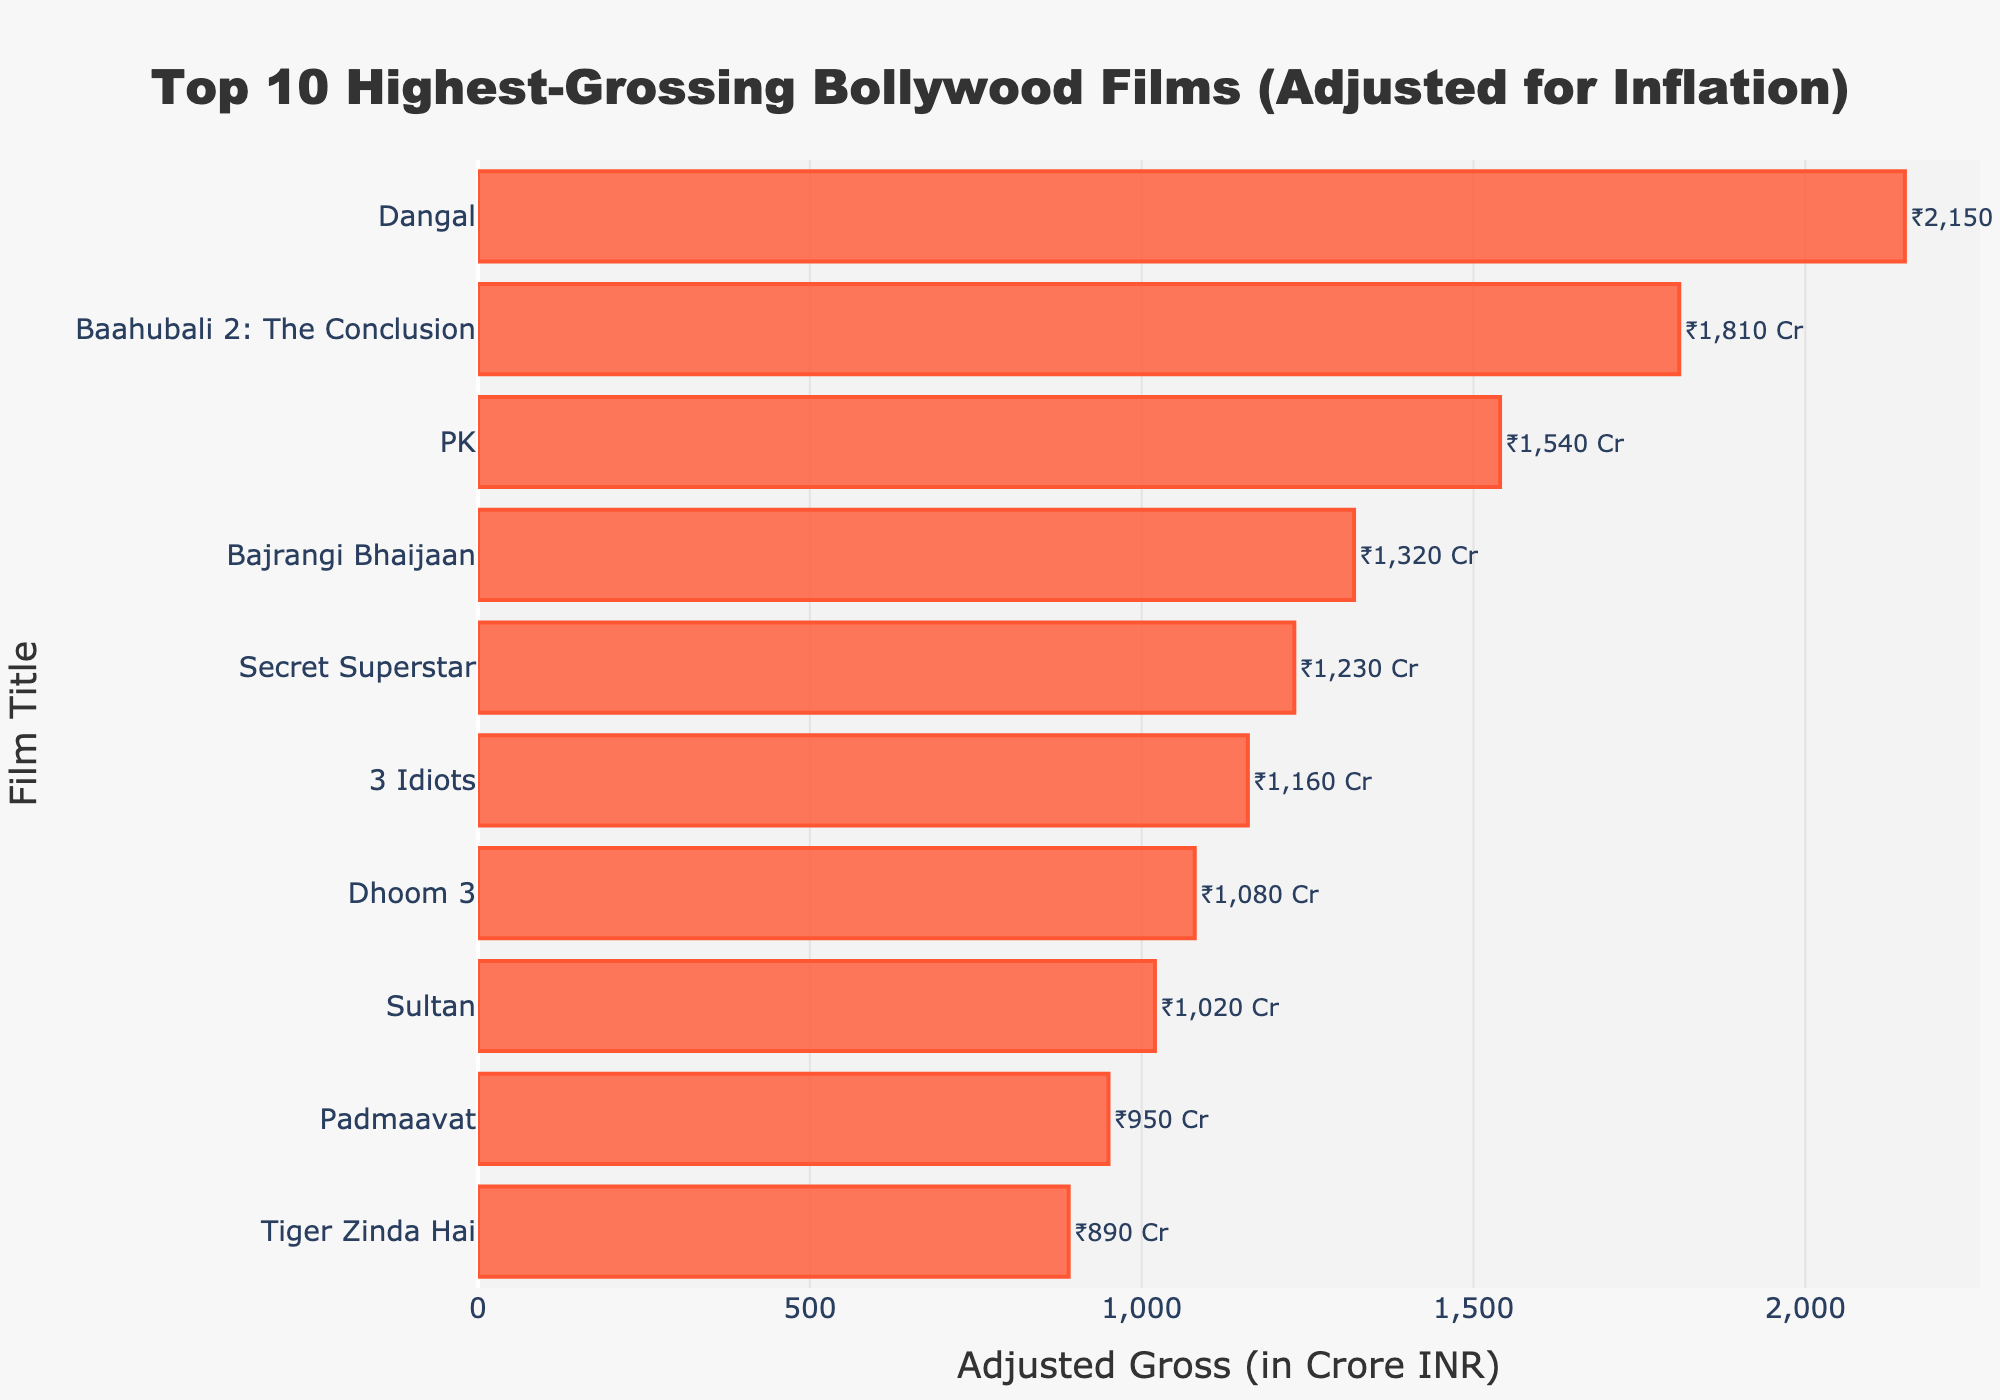Which film has the highest adjusted gross? The bar representing "Dangal" is the longest, indicating it's at the highest value on the x-axis.
Answer: Dangal What's the difference in adjusted gross between "Dangal" and "Baahubali 2: The Conclusion"? The bar for "Dangal" ends at 2150 Crore INR while "Baahubali 2: The Conclusion" ends at 1810 Crore INR. Subtracting these: 2150 - 1810 = 340.
Answer: 340 Crore INR Which film has the lowest adjusted gross in this list? The shortest bar in the chart represents "Tiger Zinda Hai," showing it has the lowest value.
Answer: Tiger Zinda Hai What's the combined adjusted gross of "PK" and "3 Idiots"? The bar for "PK" shows 1540 Crore INR, and the bar for "3 Idiots" shows 1160 Crore INR. Their combined adjusted gross is 1540 + 1160 = 2700.
Answer: 2700 Crore INR Compare the adjusted gross of "Secret Superstar" and "Bajrangi Bhaijaan." Which one is higher? The bar for "Secret Superstar" is slightly longer than the bar for "Bajrangi Bhaijaan," indicating it has a higher adjusted gross.
Answer: Secret Superstar What is the average adjusted gross of the top 3 films? The top 3 films are "Dangal" (2150 Crore INR), "Baahubali 2: The Conclusion" (1810 Crore INR), and "PK" (1540 Crore INR). Their sum is 2150 + 1810 + 1540 = 5500 Crore INR, and the average is 5500 / 3 = 1833.33 Crore INR.
Answer: 1833.33 Crore INR How many films have an adjusted gross above 1500 Crore INR? The bars for "Dangal" (2150 Crore INR), "Baahubali 2: The Conclusion" (1810 Crore INR), and "PK" (1540 Crore INR) all extend past 1500 Crore INR.
Answer: 3 films List the films with an adjusted gross between 900 and 1200 Crore INR. The bars for "Secret Superstar" (1230 Crore INR), "3 Idiots" (1160 Crore INR), "Dhoom 3" (1080 Crore INR), "Sultan" (1020 Crore INR), and "Padmaavat" (950 Crore INR) fall within the range of 900 to 1200 Crore INR.
Answer: Secret Superstar, 3 Idiots, Dhoom 3, Sultan, Padmaavat 